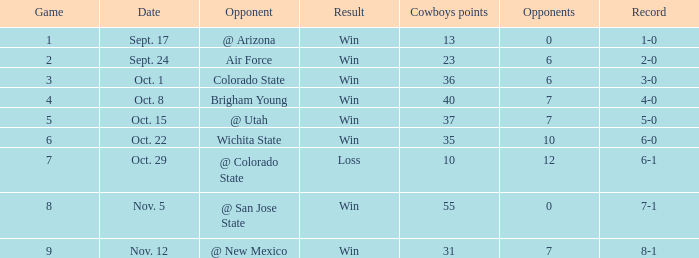What was the cowboys' standing for nov. 5, 1966? 7-1. 